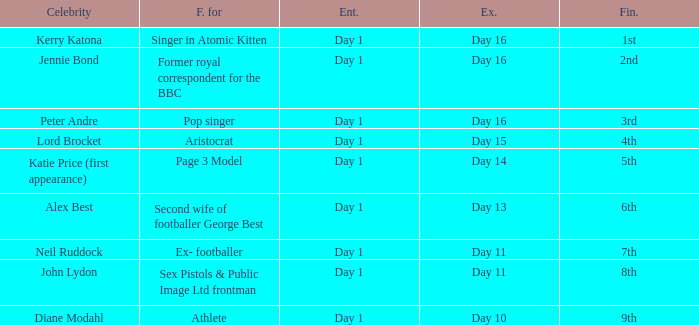Name the finished for exited of day 13 6th. 